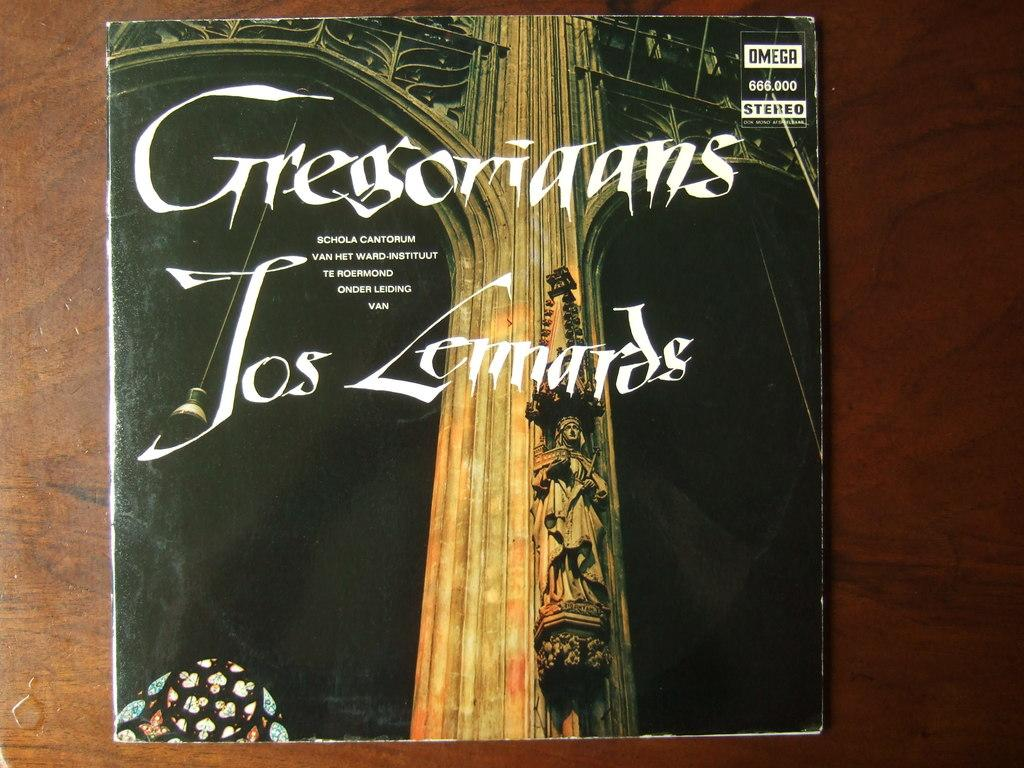Provide a one-sentence caption for the provided image. A CD of Gregoriaans Jos Lennardes laying on a brown table. 